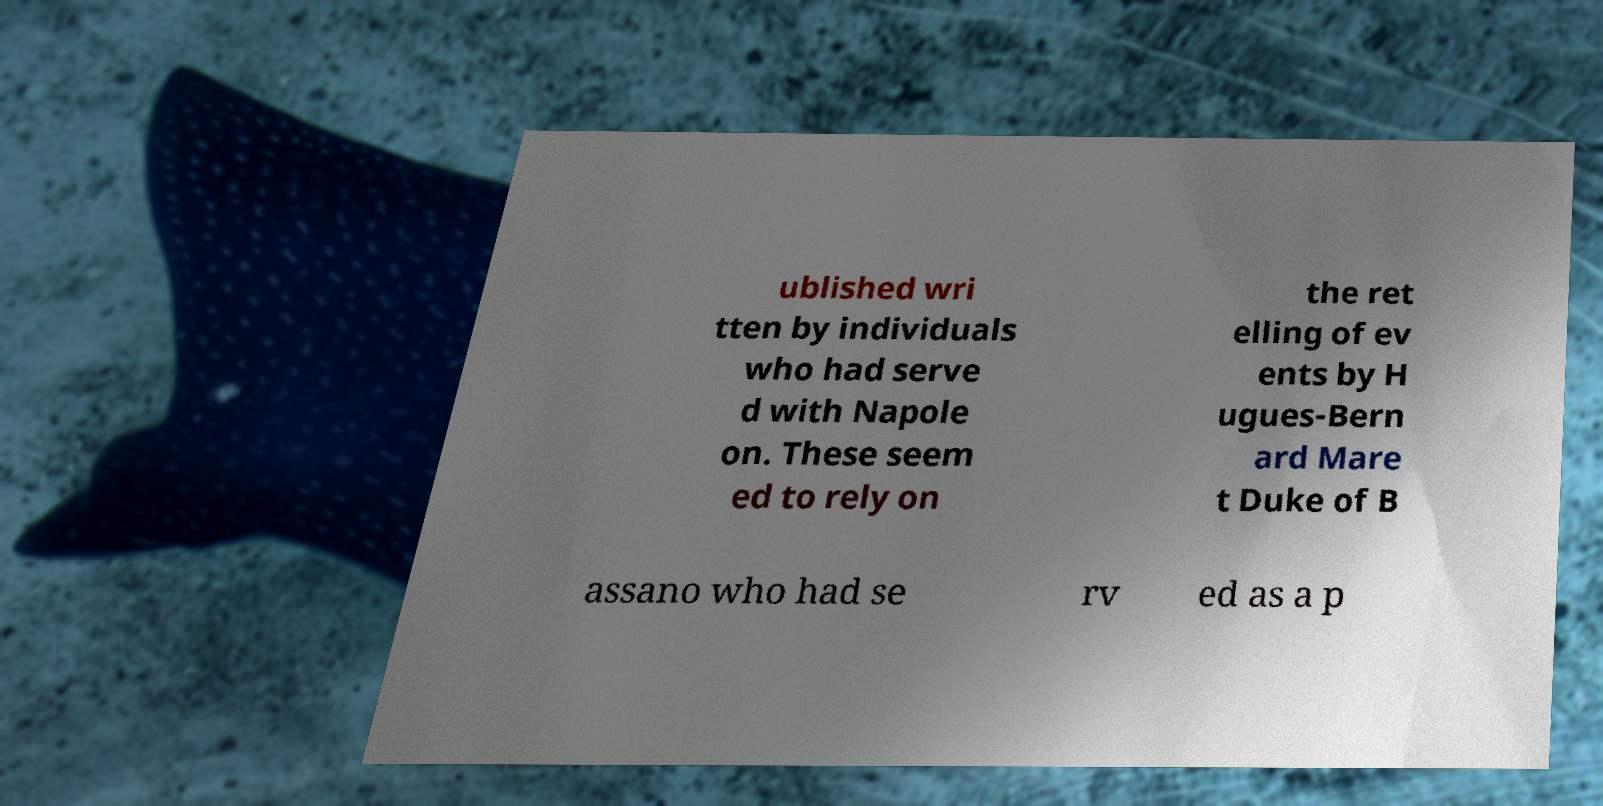Could you extract and type out the text from this image? ublished wri tten by individuals who had serve d with Napole on. These seem ed to rely on the ret elling of ev ents by H ugues-Bern ard Mare t Duke of B assano who had se rv ed as a p 